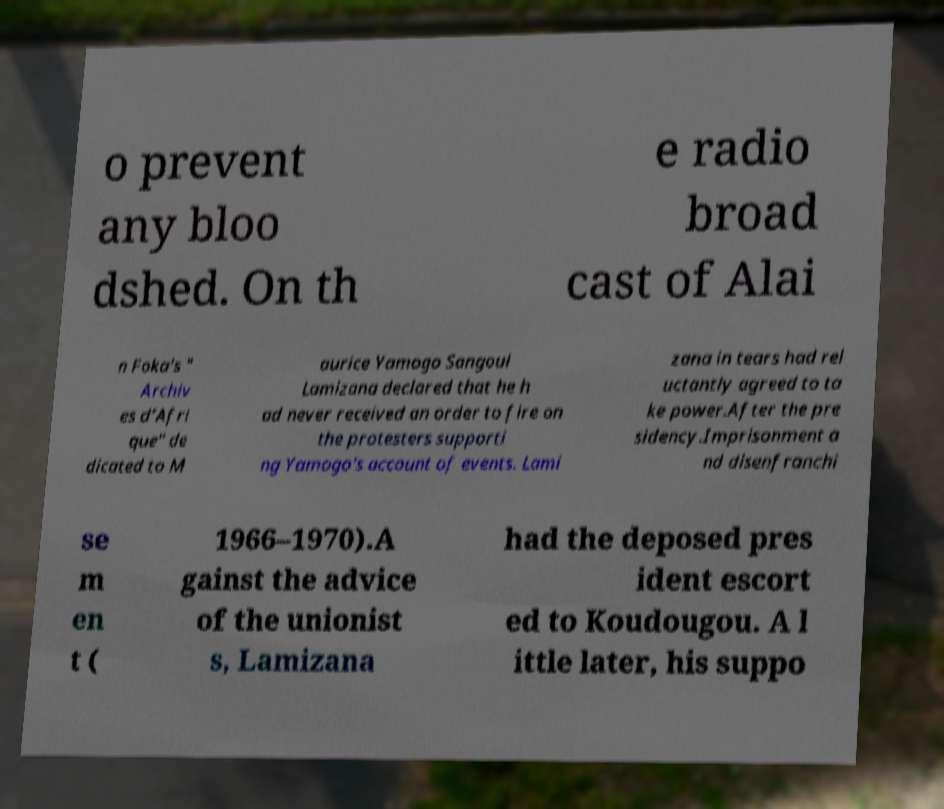For documentation purposes, I need the text within this image transcribed. Could you provide that? o prevent any bloo dshed. On th e radio broad cast of Alai n Foka's " Archiv es d’Afri que" de dicated to M aurice Yamogo Sangoul Lamizana declared that he h ad never received an order to fire on the protesters supporti ng Yamogo's account of events. Lami zana in tears had rel uctantly agreed to ta ke power.After the pre sidency.Imprisonment a nd disenfranchi se m en t ( 1966–1970).A gainst the advice of the unionist s, Lamizana had the deposed pres ident escort ed to Koudougou. A l ittle later, his suppo 